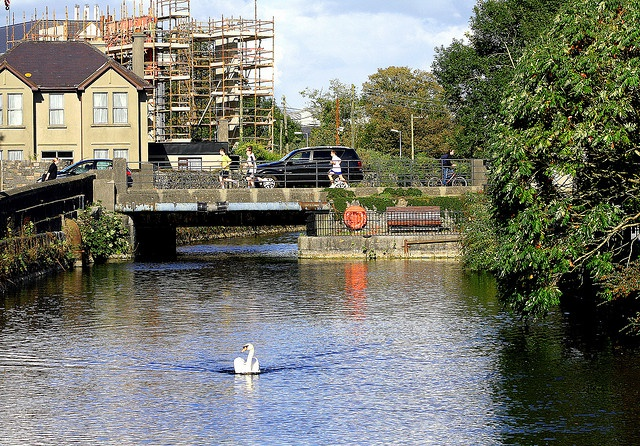Describe the objects in this image and their specific colors. I can see truck in lightgray, black, gray, darkgray, and white tones, car in lightgray, black, gray, darkgray, and white tones, bench in lightgray, gray, darkgray, and black tones, bird in lightgray, white, darkgray, and black tones, and car in lightgray, black, gray, and darkgray tones in this image. 